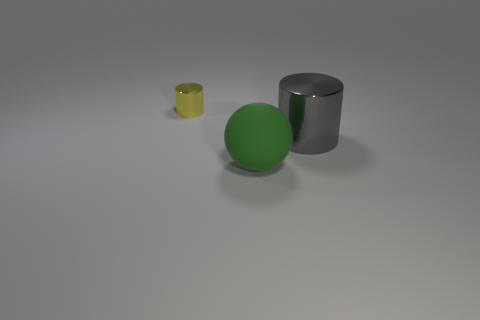Can you describe the texture and material of the objects in the image? Sure! In the image, there are three objects, each with a distinct texture and material. The yellow object on the left appears to be a small cup made of a translucent material, possibly plastic. The central green object is a rubber ball with a matte surface, implying a soft, pliable texture. The gray object on the right is a cylinder with a reflective surface, suggesting it's made of metal, most likely steel or aluminum. 